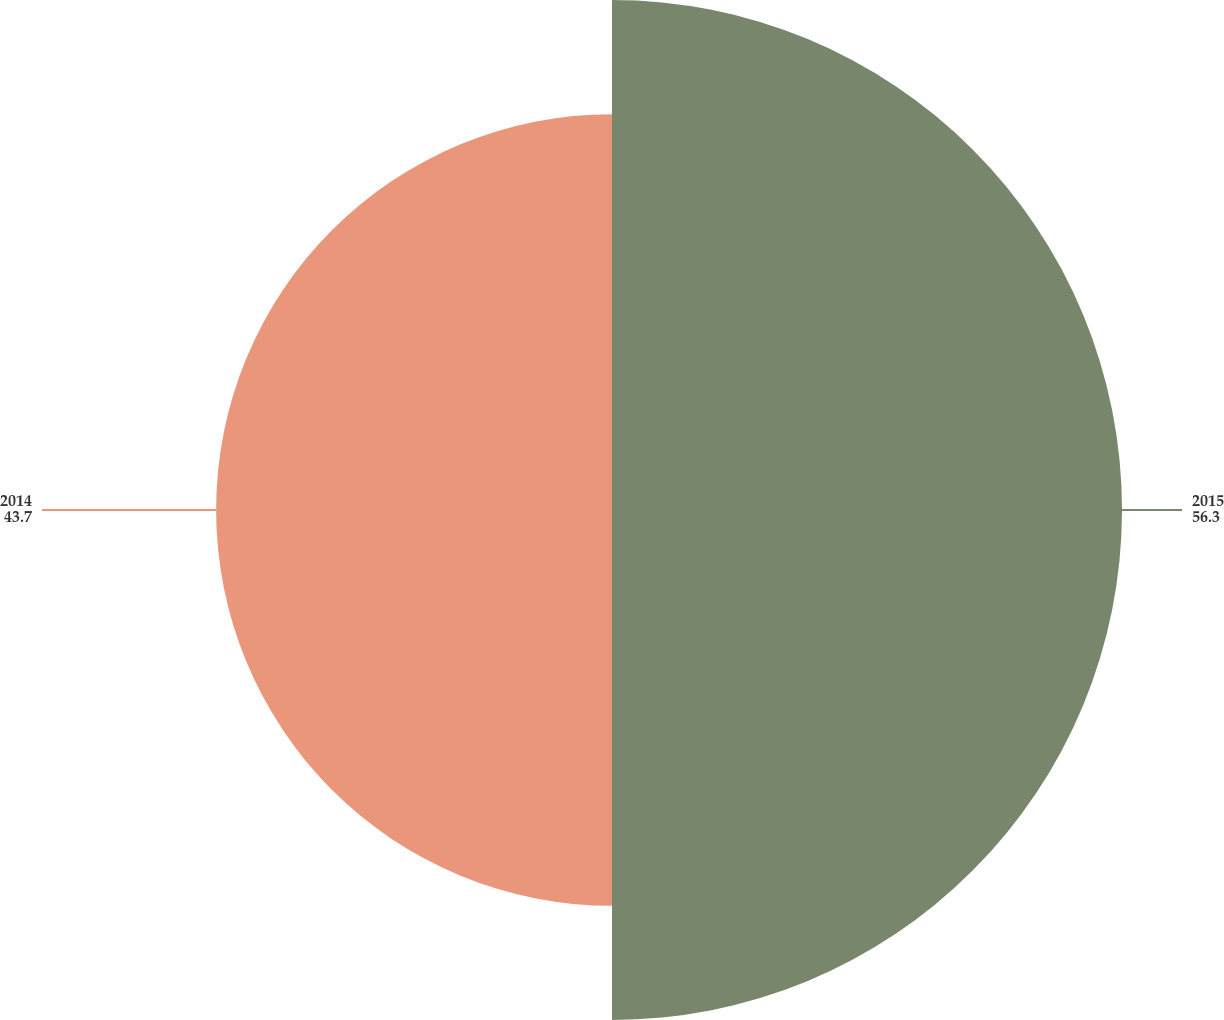Convert chart to OTSL. <chart><loc_0><loc_0><loc_500><loc_500><pie_chart><fcel>2015<fcel>2014<nl><fcel>56.3%<fcel>43.7%<nl></chart> 